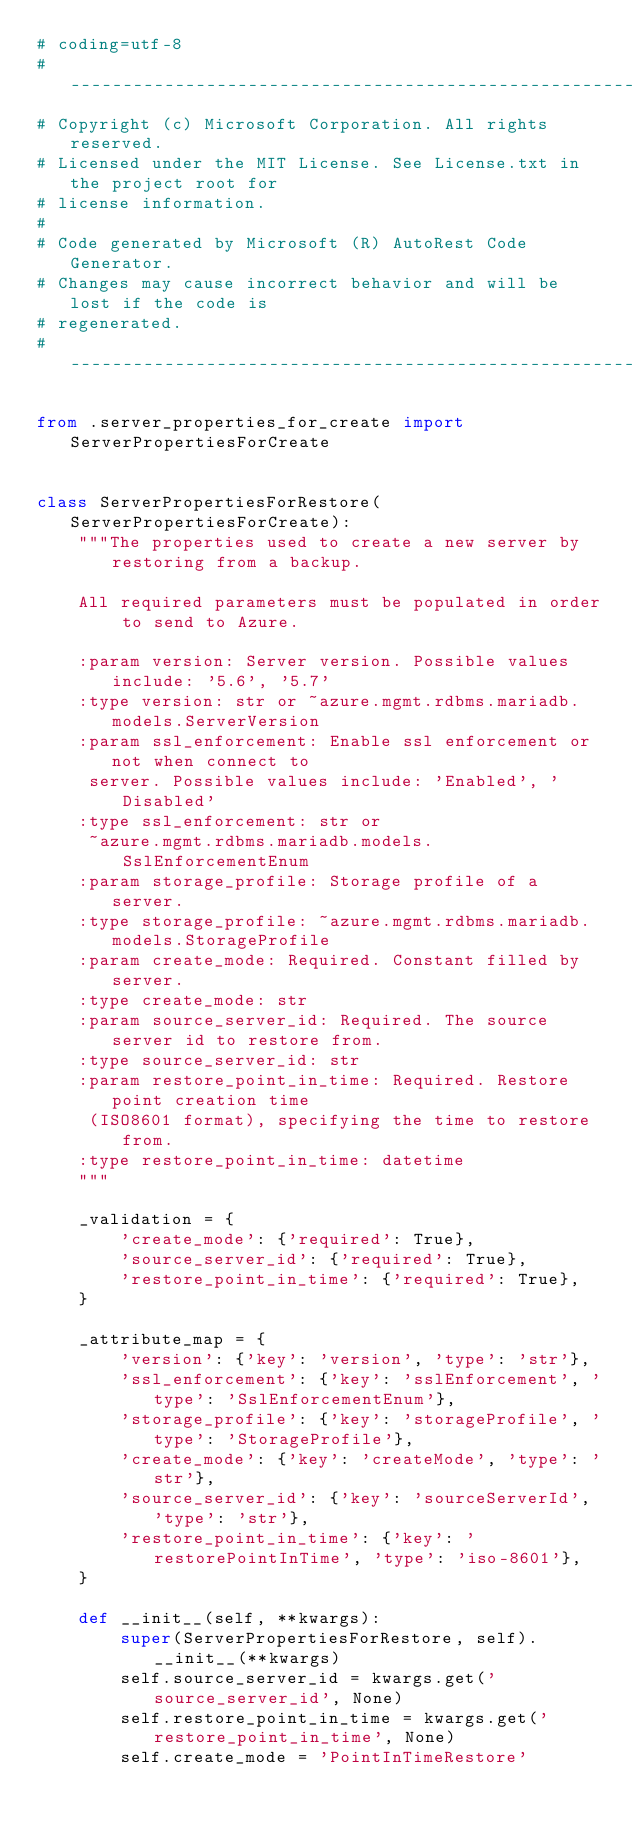<code> <loc_0><loc_0><loc_500><loc_500><_Python_># coding=utf-8
# --------------------------------------------------------------------------
# Copyright (c) Microsoft Corporation. All rights reserved.
# Licensed under the MIT License. See License.txt in the project root for
# license information.
#
# Code generated by Microsoft (R) AutoRest Code Generator.
# Changes may cause incorrect behavior and will be lost if the code is
# regenerated.
# --------------------------------------------------------------------------

from .server_properties_for_create import ServerPropertiesForCreate


class ServerPropertiesForRestore(ServerPropertiesForCreate):
    """The properties used to create a new server by restoring from a backup.

    All required parameters must be populated in order to send to Azure.

    :param version: Server version. Possible values include: '5.6', '5.7'
    :type version: str or ~azure.mgmt.rdbms.mariadb.models.ServerVersion
    :param ssl_enforcement: Enable ssl enforcement or not when connect to
     server. Possible values include: 'Enabled', 'Disabled'
    :type ssl_enforcement: str or
     ~azure.mgmt.rdbms.mariadb.models.SslEnforcementEnum
    :param storage_profile: Storage profile of a server.
    :type storage_profile: ~azure.mgmt.rdbms.mariadb.models.StorageProfile
    :param create_mode: Required. Constant filled by server.
    :type create_mode: str
    :param source_server_id: Required. The source server id to restore from.
    :type source_server_id: str
    :param restore_point_in_time: Required. Restore point creation time
     (ISO8601 format), specifying the time to restore from.
    :type restore_point_in_time: datetime
    """

    _validation = {
        'create_mode': {'required': True},
        'source_server_id': {'required': True},
        'restore_point_in_time': {'required': True},
    }

    _attribute_map = {
        'version': {'key': 'version', 'type': 'str'},
        'ssl_enforcement': {'key': 'sslEnforcement', 'type': 'SslEnforcementEnum'},
        'storage_profile': {'key': 'storageProfile', 'type': 'StorageProfile'},
        'create_mode': {'key': 'createMode', 'type': 'str'},
        'source_server_id': {'key': 'sourceServerId', 'type': 'str'},
        'restore_point_in_time': {'key': 'restorePointInTime', 'type': 'iso-8601'},
    }

    def __init__(self, **kwargs):
        super(ServerPropertiesForRestore, self).__init__(**kwargs)
        self.source_server_id = kwargs.get('source_server_id', None)
        self.restore_point_in_time = kwargs.get('restore_point_in_time', None)
        self.create_mode = 'PointInTimeRestore'
</code> 